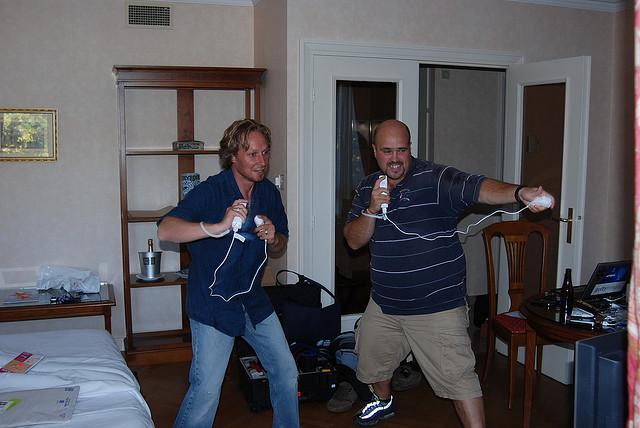How many pictures are on the wall?
Answer briefly. 1. What type of pants is the man wearing?
Concise answer only. Jeans. What kind of facial hair does the man have?
Keep it brief. Mustache. What sport is this man playing?
Write a very short answer. Wii. How old is the girl?
Concise answer only. 30. How many people are in the picture?
Be succinct. 2. Are there any  stuffed animals in this photo?
Quick response, please. No. What is the person doing?
Quick response, please. Playing wii. Why is one man particularly happy?
Keep it brief. Winning. What are the men doing?
Quick response, please. Playing wii. Are the men engaged in serious work?
Write a very short answer. No. Are they outside?
Give a very brief answer. No. Is anyone kneeling on the floor?
Concise answer only. No. Is there a man and a woman?
Keep it brief. No. Whose shirt is green?
Write a very short answer. Neither. Did the man push the woman over?
Short answer required. No. 